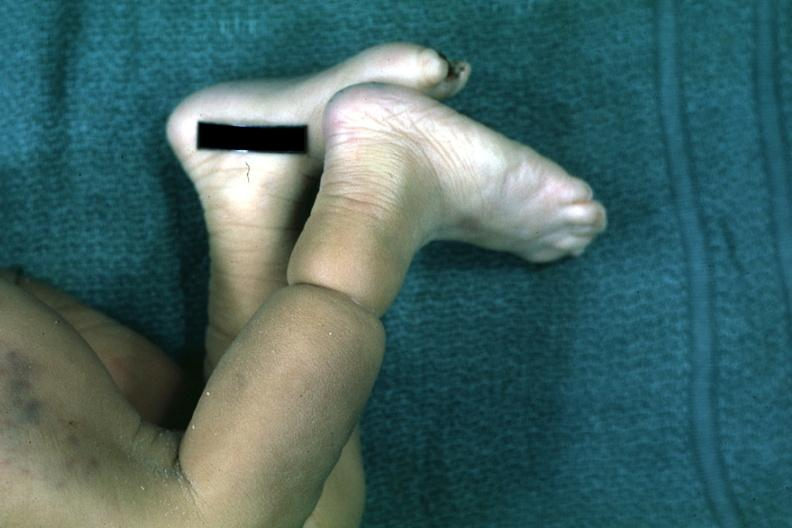what is that like an amniotic band lesion?
Answer the question using a single word or phrase. Looks 